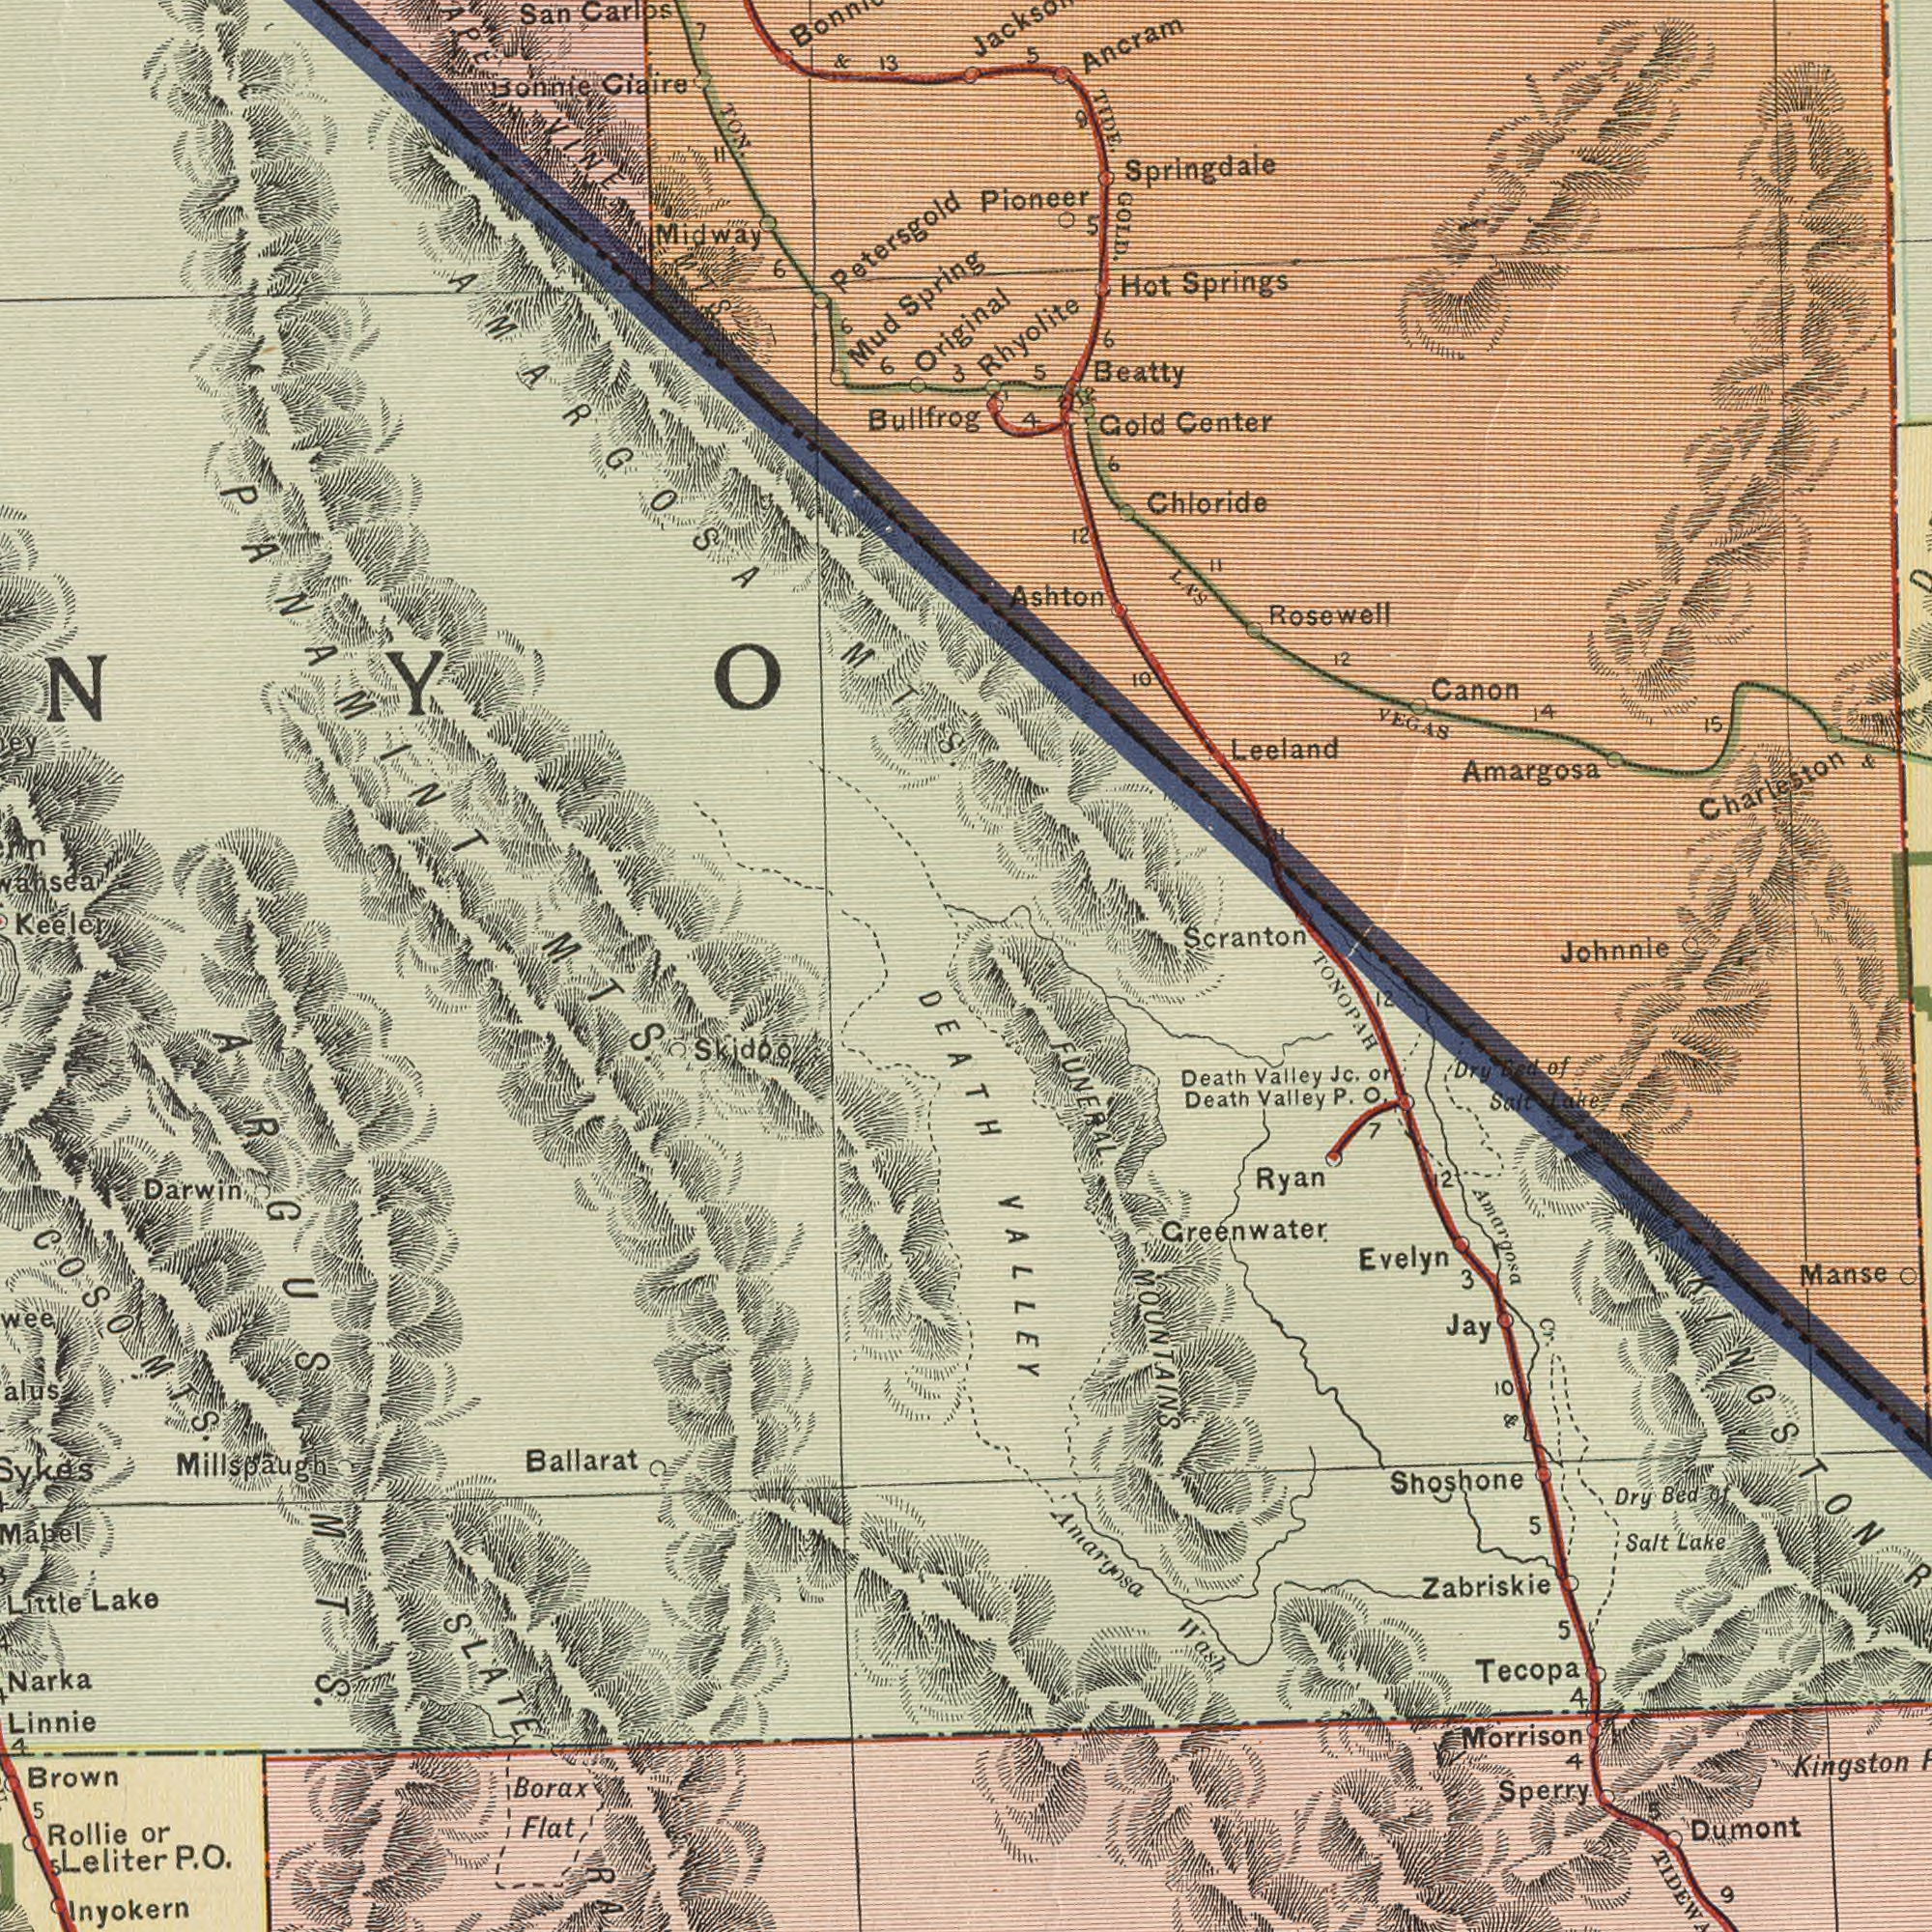What text can you see in the bottom-left section? Inyokern Rollie Darwin Brown Narka Ballarat Skidoo Millspaugh Flat P. Little Linnie Lake Leliter 5 Borax or ARGUS SLATE 4 MTS. 5 O. MTS. COSO MTS. What text appears in the bottom-right area of the image? FUNERAL Greenwater Amargosa Amargosa Kingston Morrison Manse Tecopa Dumont Death Evelyn Wash Ryan Salt TONOPAH MOUNTAINS Sperry Jay TIDEW Dry Lake Zabriskie Death Bed Valley Cr. Jc. Valley P. 3 4 5 5 Dry Shoshone 4 Salt KINGSTON 12 7 or 5 of 9 VALLEY DEATH 2 Lake O. of Bed 10 & What text is shown in the top-right quadrant? Charleston Springdale Ancram Amargosa TIDE. Leeland Ashton Springs Johnnie Center Rosewell Gold Canon Beatty Hot Scranton Rhyolite VEGAS Chloride 4 Pioneer 12 12 15 11 GOLD. 5 14 5 10 6 LAS 5 Original 6 9 12 11 & What text can you see in the top-left section? Petersgold Ciaire Midway Mud Keeler Carlos San Spring Bullfrog TON. VINE 13 & 6 PANAMINT 7 Bonnie AMARGOSA 3 6 6 MTS. MTS. 11 